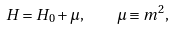<formula> <loc_0><loc_0><loc_500><loc_500>H = H _ { 0 } + \mu , \quad \mu \equiv m ^ { 2 } ,</formula> 